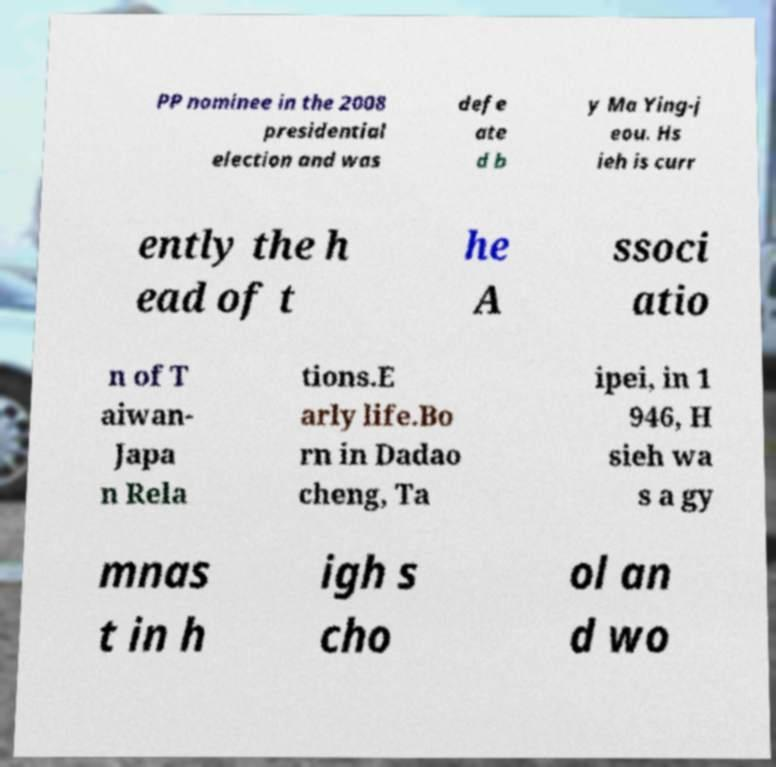Could you extract and type out the text from this image? PP nominee in the 2008 presidential election and was defe ate d b y Ma Ying-j eou. Hs ieh is curr ently the h ead of t he A ssoci atio n of T aiwan- Japa n Rela tions.E arly life.Bo rn in Dadao cheng, Ta ipei, in 1 946, H sieh wa s a gy mnas t in h igh s cho ol an d wo 